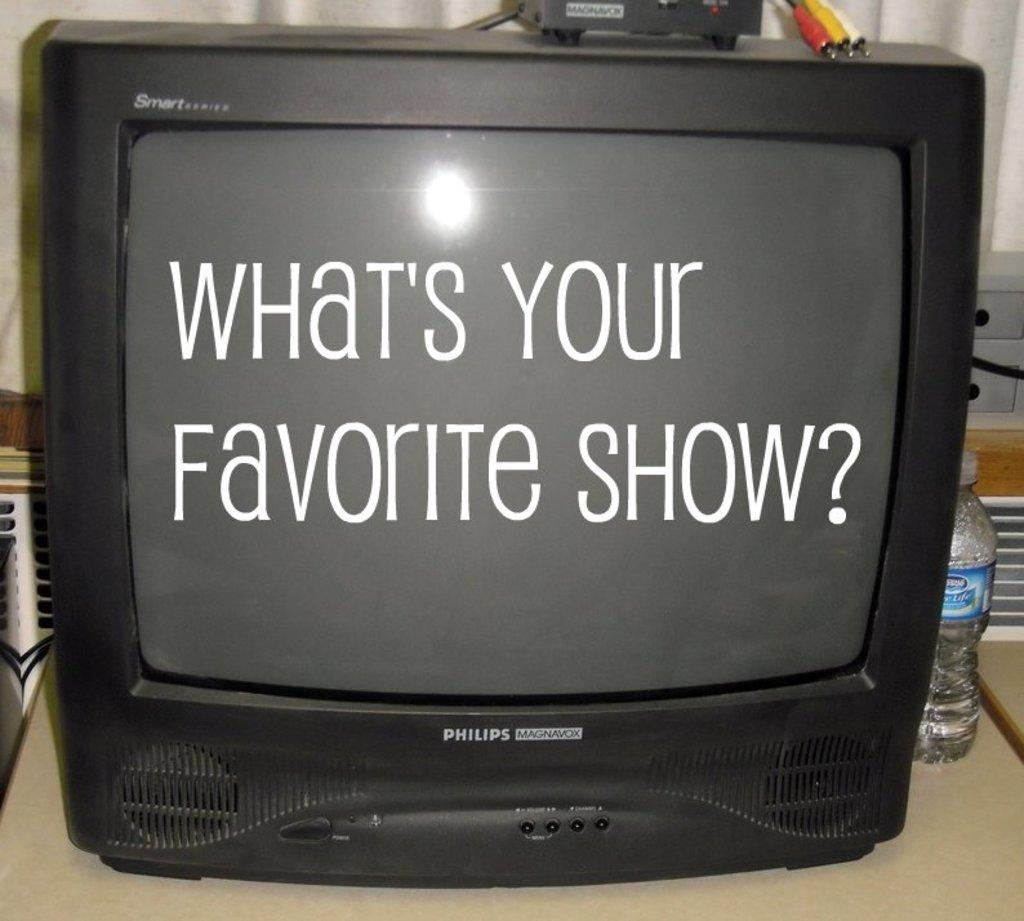<image>
Create a compact narrative representing the image presented. a television channel with the words favorite show on it 